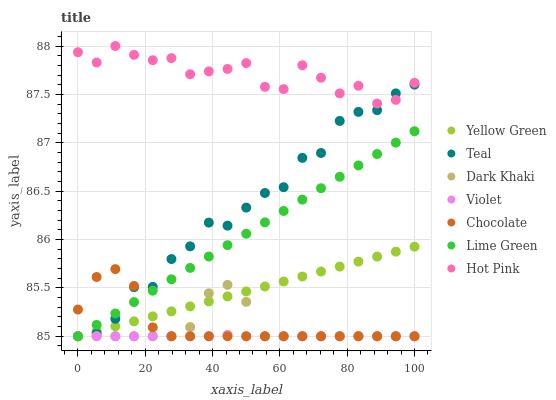Does Violet have the minimum area under the curve?
Answer yes or no. Yes. Does Hot Pink have the maximum area under the curve?
Answer yes or no. Yes. Does Chocolate have the minimum area under the curve?
Answer yes or no. No. Does Chocolate have the maximum area under the curve?
Answer yes or no. No. Is Lime Green the smoothest?
Answer yes or no. Yes. Is Hot Pink the roughest?
Answer yes or no. Yes. Is Chocolate the smoothest?
Answer yes or no. No. Is Chocolate the roughest?
Answer yes or no. No. Does Yellow Green have the lowest value?
Answer yes or no. Yes. Does Hot Pink have the lowest value?
Answer yes or no. No. Does Hot Pink have the highest value?
Answer yes or no. Yes. Does Chocolate have the highest value?
Answer yes or no. No. Is Chocolate less than Hot Pink?
Answer yes or no. Yes. Is Hot Pink greater than Violet?
Answer yes or no. Yes. Does Chocolate intersect Teal?
Answer yes or no. Yes. Is Chocolate less than Teal?
Answer yes or no. No. Is Chocolate greater than Teal?
Answer yes or no. No. Does Chocolate intersect Hot Pink?
Answer yes or no. No. 